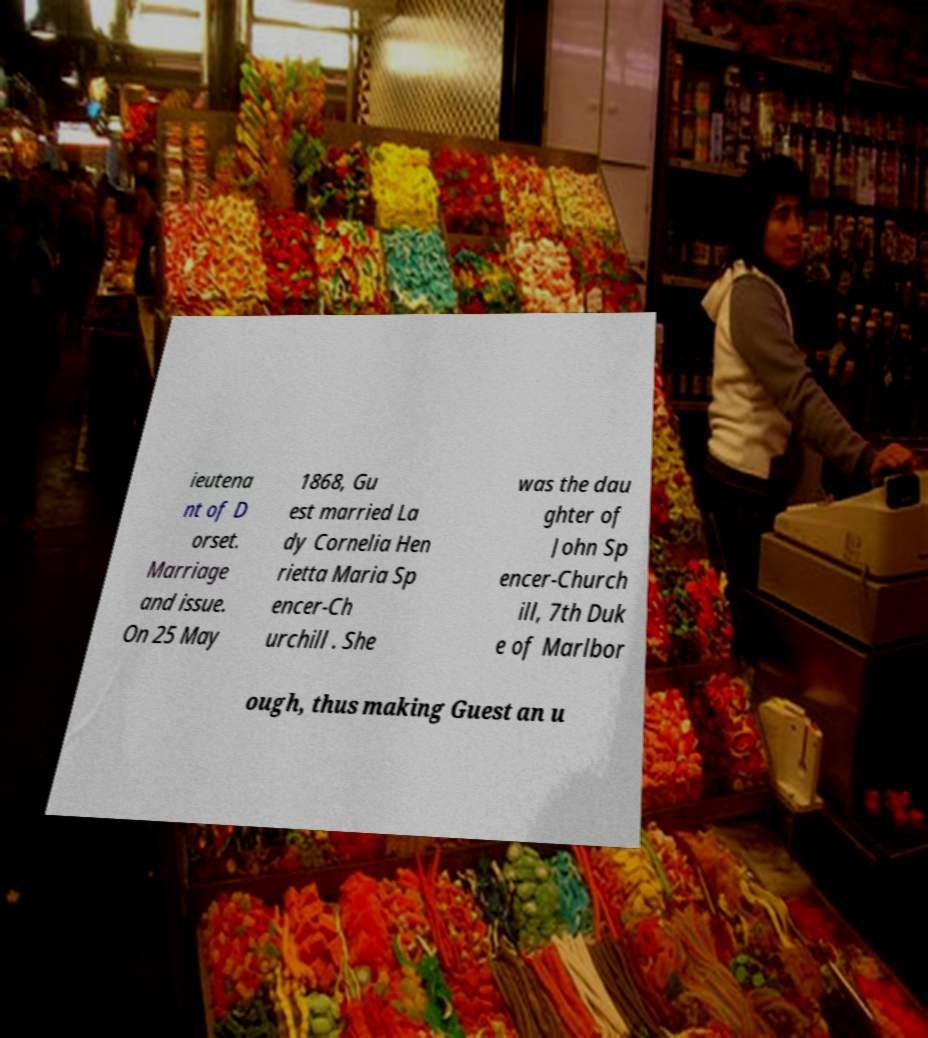Please identify and transcribe the text found in this image. ieutena nt of D orset. Marriage and issue. On 25 May 1868, Gu est married La dy Cornelia Hen rietta Maria Sp encer-Ch urchill . She was the dau ghter of John Sp encer-Church ill, 7th Duk e of Marlbor ough, thus making Guest an u 